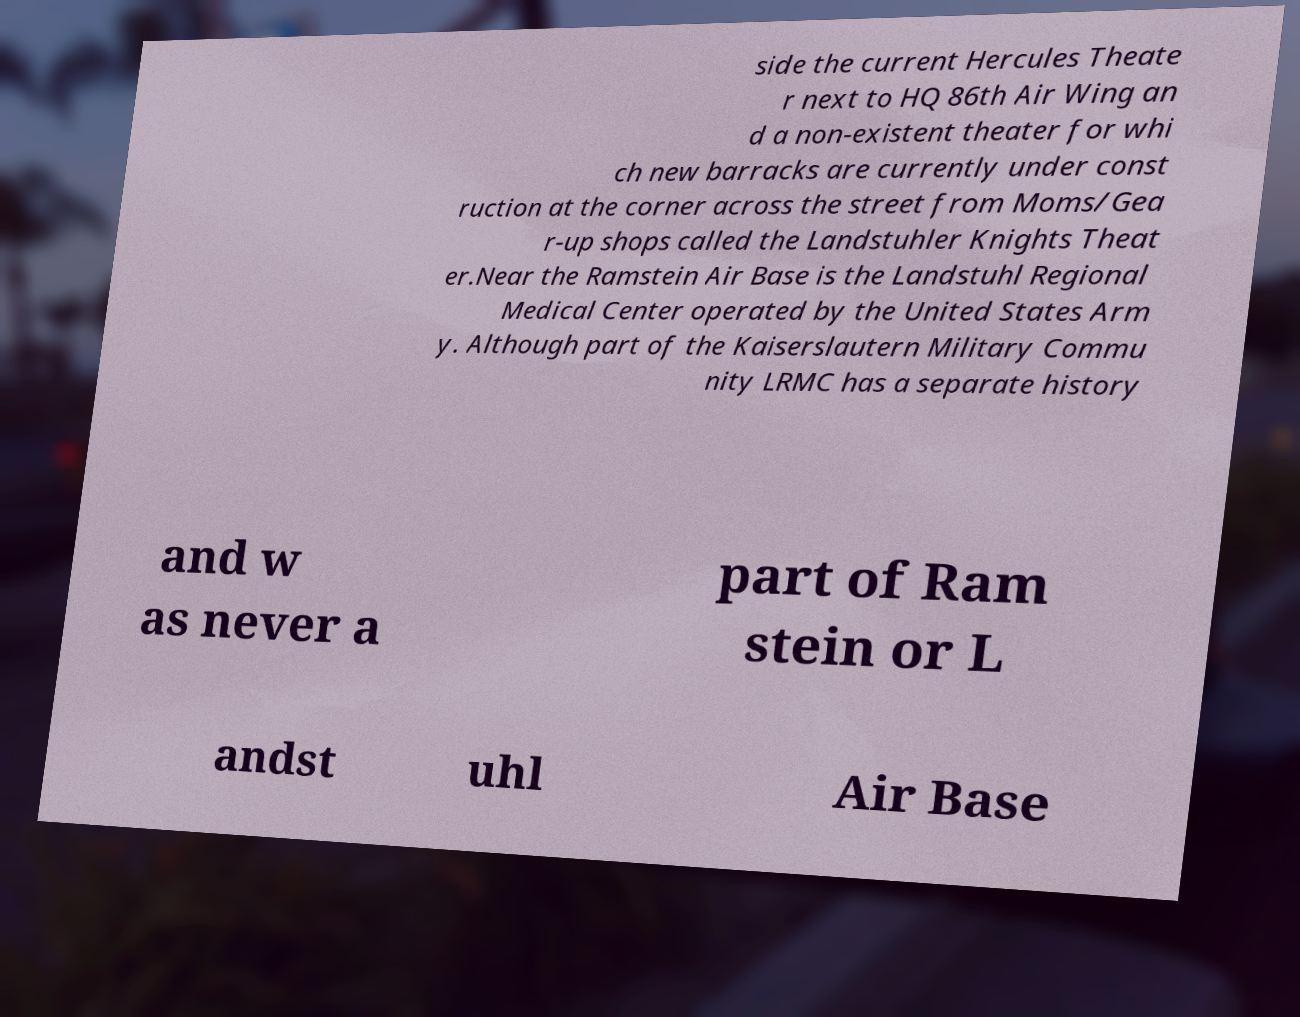I need the written content from this picture converted into text. Can you do that? side the current Hercules Theate r next to HQ 86th Air Wing an d a non-existent theater for whi ch new barracks are currently under const ruction at the corner across the street from Moms/Gea r-up shops called the Landstuhler Knights Theat er.Near the Ramstein Air Base is the Landstuhl Regional Medical Center operated by the United States Arm y. Although part of the Kaiserslautern Military Commu nity LRMC has a separate history and w as never a part of Ram stein or L andst uhl Air Base 